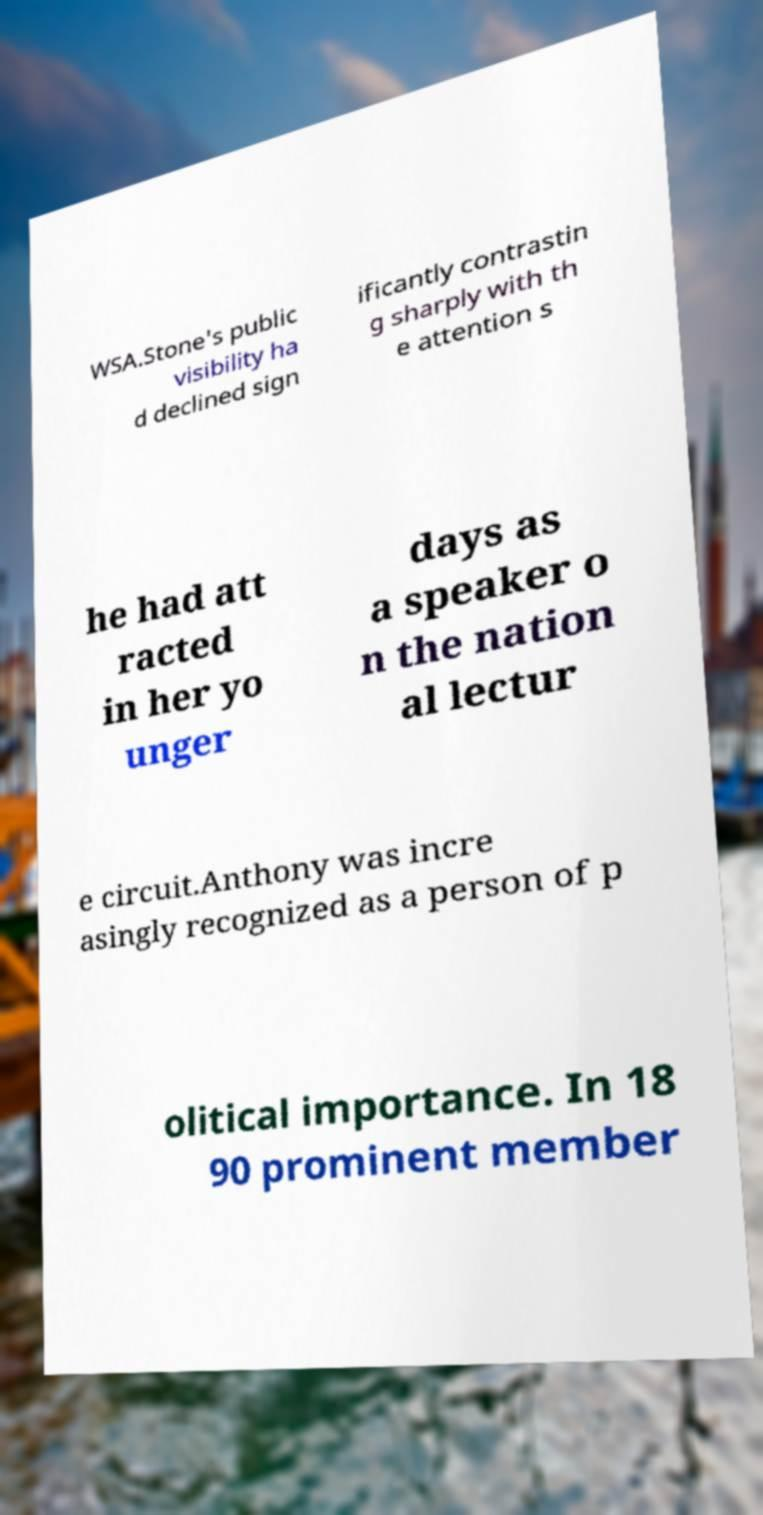Can you read and provide the text displayed in the image?This photo seems to have some interesting text. Can you extract and type it out for me? WSA.Stone's public visibility ha d declined sign ificantly contrastin g sharply with th e attention s he had att racted in her yo unger days as a speaker o n the nation al lectur e circuit.Anthony was incre asingly recognized as a person of p olitical importance. In 18 90 prominent member 